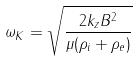Convert formula to latex. <formula><loc_0><loc_0><loc_500><loc_500>\omega _ { K } = \sqrt { \frac { 2 k _ { z } B ^ { 2 } } { \mu ( \rho _ { i } + \rho _ { e } ) } }</formula> 